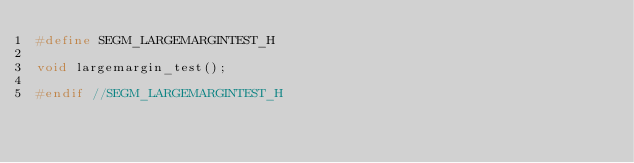<code> <loc_0><loc_0><loc_500><loc_500><_C_>#define SEGM_LARGEMARGINTEST_H

void largemargin_test();

#endif //SEGM_LARGEMARGINTEST_H
</code> 